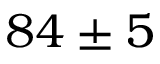Convert formula to latex. <formula><loc_0><loc_0><loc_500><loc_500>8 4 \pm 5</formula> 